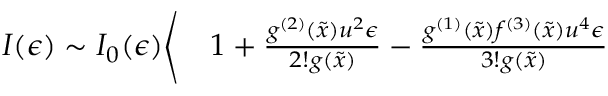<formula> <loc_0><loc_0><loc_500><loc_500>\begin{array} { r l } { I ( \epsilon ) \sim I _ { 0 } ( \epsilon ) \Big \langle } & 1 + \frac { g ^ { ( 2 ) } ( \tilde { x } ) u ^ { 2 } \epsilon } { 2 ! g ( \tilde { x } ) } - \frac { g ^ { ( 1 ) } ( \tilde { x } ) f ^ { ( 3 ) } ( \tilde { x } ) u ^ { 4 } \epsilon } { 3 ! g ( \tilde { x } ) } } \end{array}</formula> 